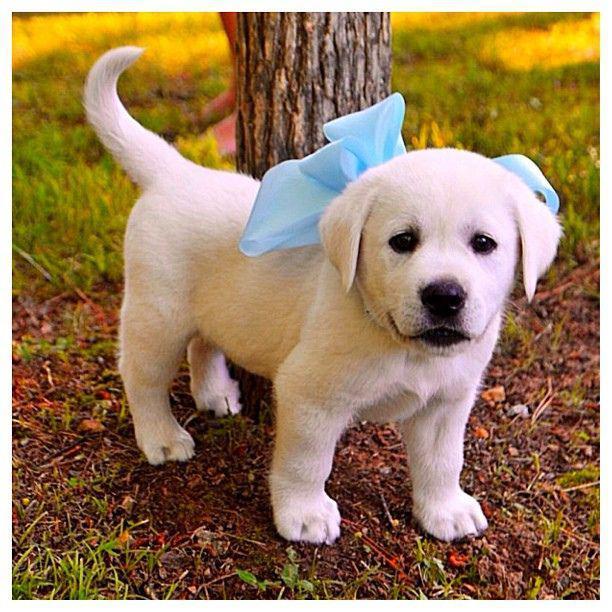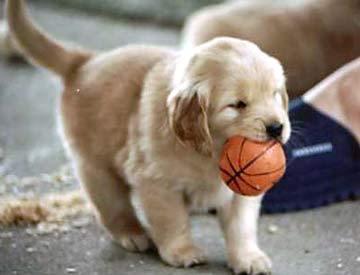The first image is the image on the left, the second image is the image on the right. For the images shown, is this caption "One dog has something around its neck." true? Answer yes or no. Yes. The first image is the image on the left, the second image is the image on the right. Analyze the images presented: Is the assertion "there are two puppies in the image pair" valid? Answer yes or no. Yes. 